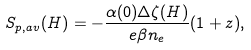<formula> <loc_0><loc_0><loc_500><loc_500>S _ { p , a v } ( H ) = - \frac { \alpha ( 0 ) \Delta \zeta ( H ) } { e \beta n _ { e } } ( 1 + z ) ,</formula> 